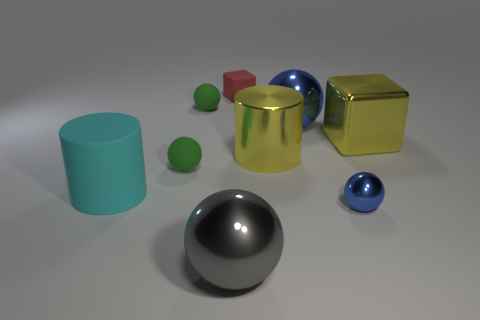Subtract all blocks. How many objects are left? 7 Add 7 small green matte balls. How many small green matte balls exist? 9 Subtract 0 green cylinders. How many objects are left? 9 Subtract all tiny green rubber spheres. Subtract all gray metallic spheres. How many objects are left? 6 Add 2 tiny rubber balls. How many tiny rubber balls are left? 4 